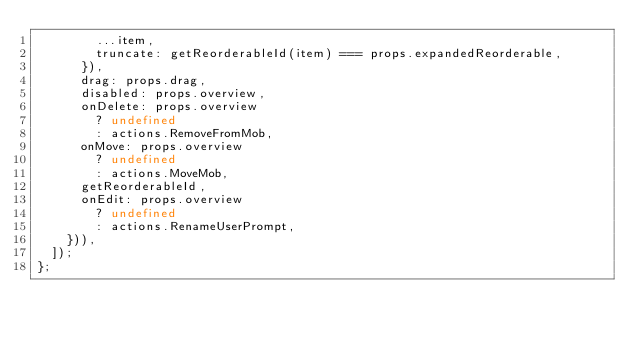<code> <loc_0><loc_0><loc_500><loc_500><_JavaScript_>        ...item,
        truncate: getReorderableId(item) === props.expandedReorderable,
      }),
      drag: props.drag,
      disabled: props.overview,
      onDelete: props.overview
        ? undefined
        : actions.RemoveFromMob,
      onMove: props.overview
        ? undefined
        : actions.MoveMob,
      getReorderableId,
      onEdit: props.overview
        ? undefined
        : actions.RenameUserPrompt,
    })),
  ]);
};
</code> 